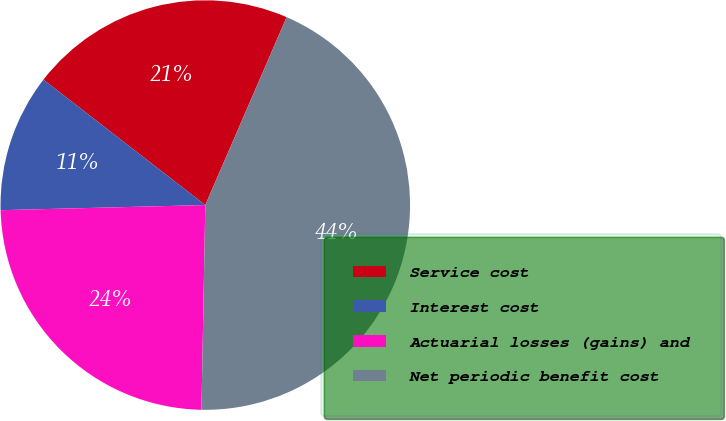Convert chart. <chart><loc_0><loc_0><loc_500><loc_500><pie_chart><fcel>Service cost<fcel>Interest cost<fcel>Actuarial losses (gains) and<fcel>Net periodic benefit cost<nl><fcel>21.01%<fcel>10.89%<fcel>24.3%<fcel>43.8%<nl></chart> 